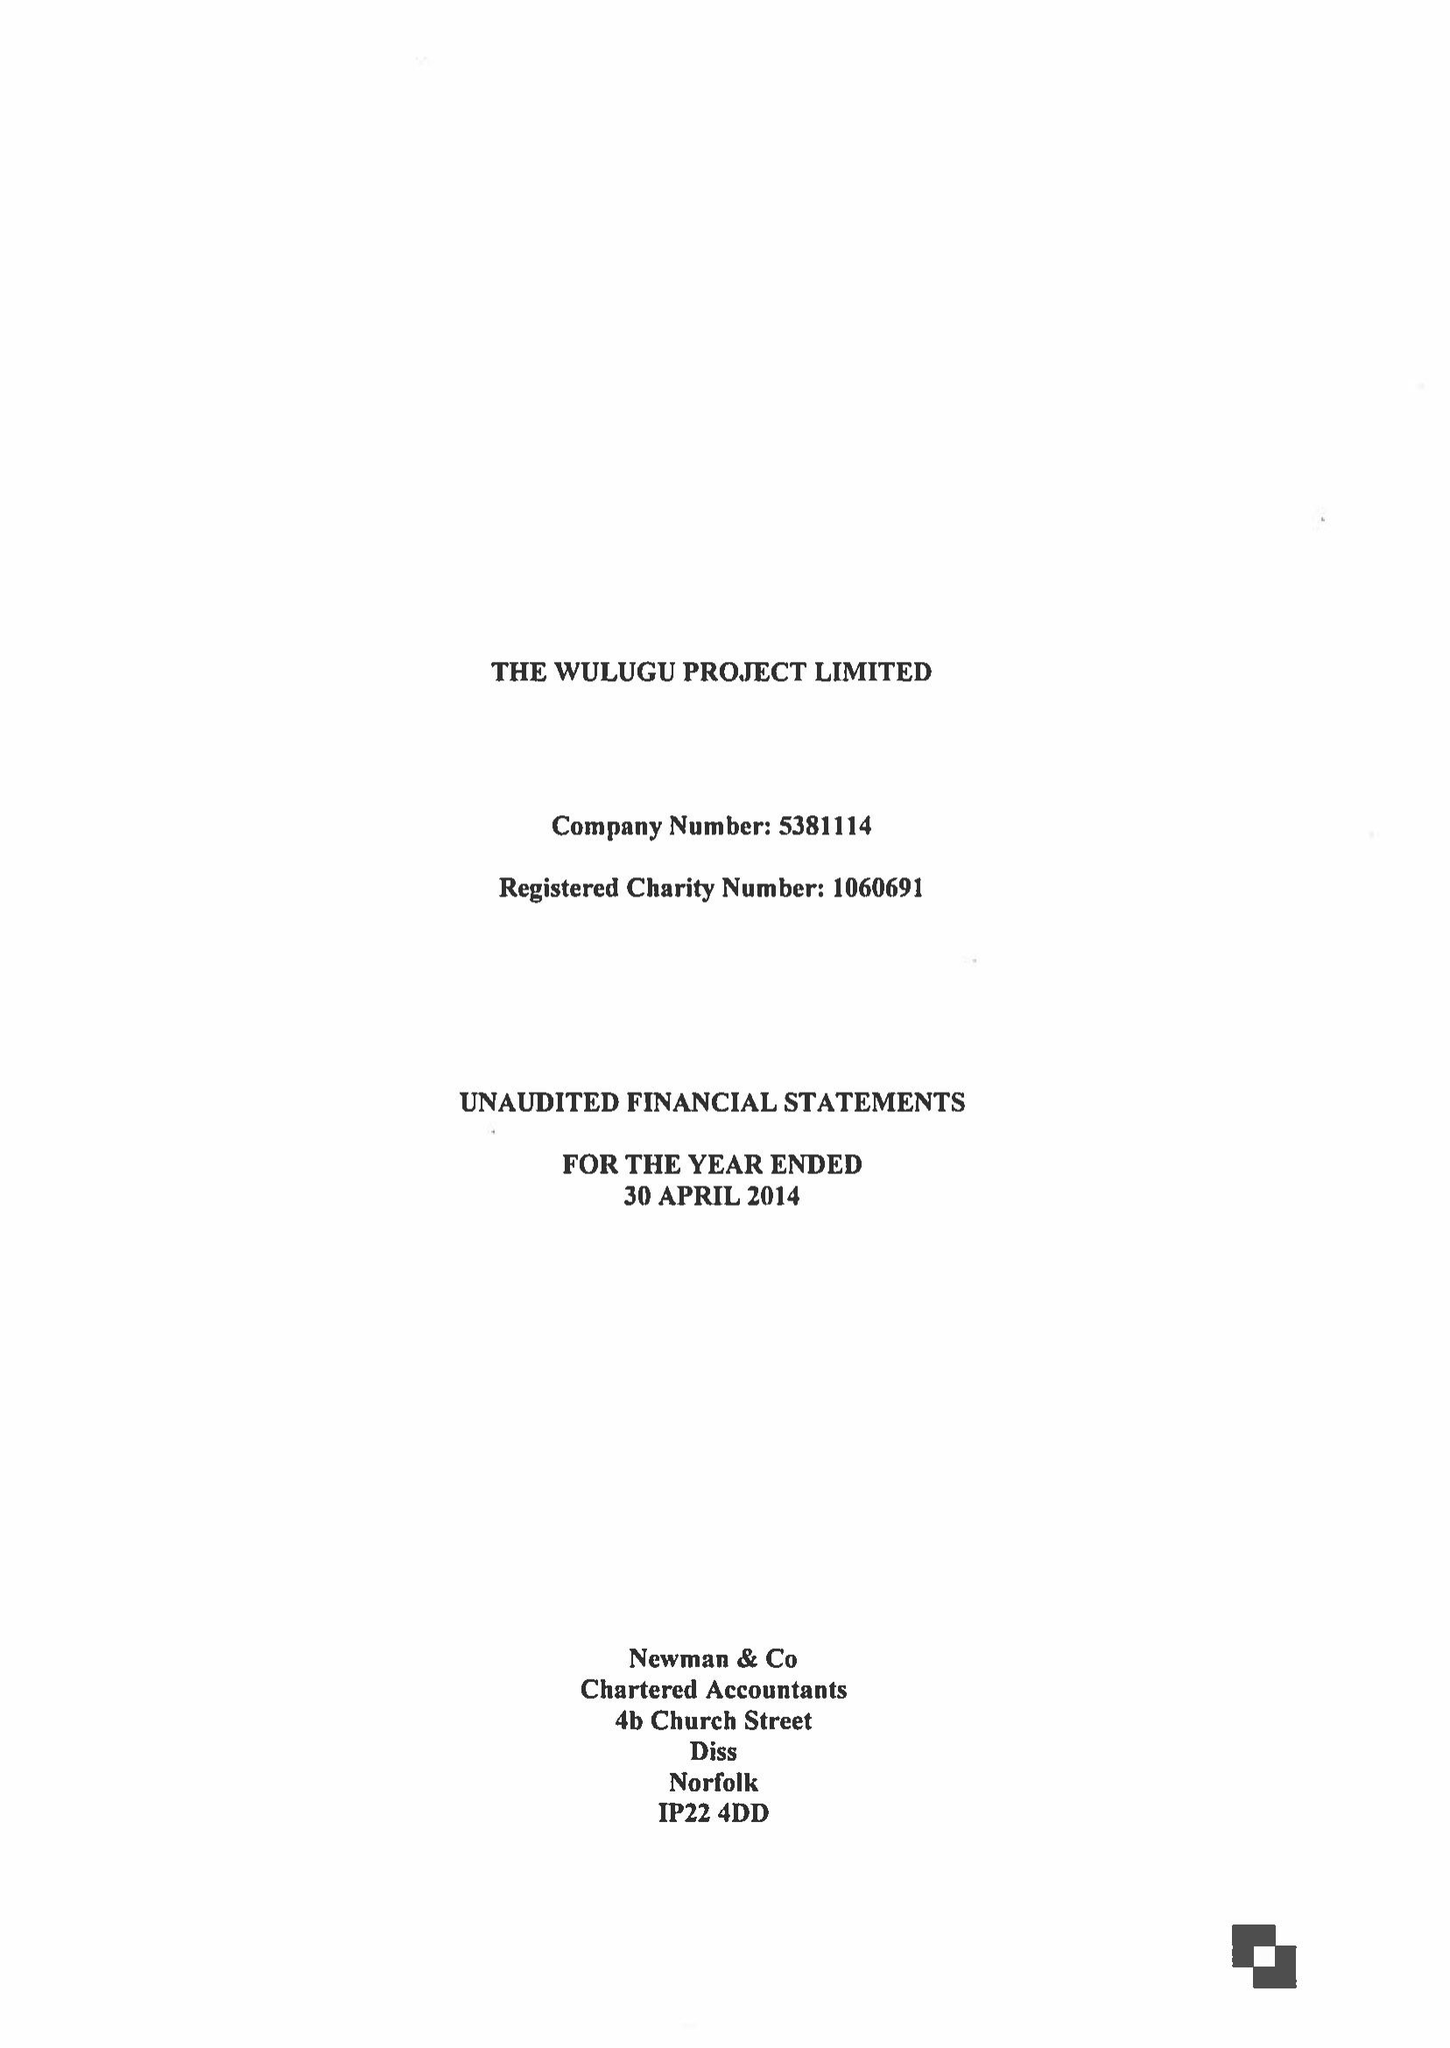What is the value for the charity_name?
Answer the question using a single word or phrase. The Wulugu Project Ltd. 